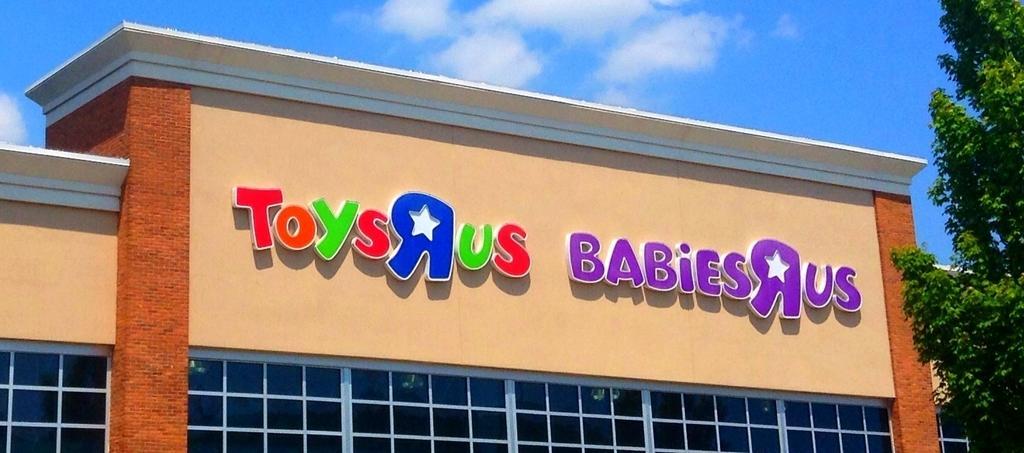Can you describe this image briefly? This is an outside view. Here I can see a building and there are few letter blocks attached to the wall. At the bottom, I can see the glass. On the right side there is a tree. At the top of the image I can see the sky and clouds. 